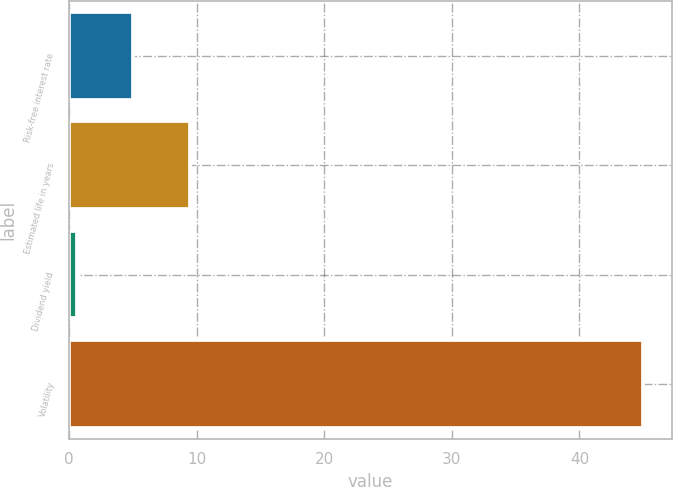Convert chart to OTSL. <chart><loc_0><loc_0><loc_500><loc_500><bar_chart><fcel>Risk-free interest rate<fcel>Estimated life in years<fcel>Dividend yield<fcel>Volatility<nl><fcel>5.04<fcel>9.48<fcel>0.6<fcel>45<nl></chart> 